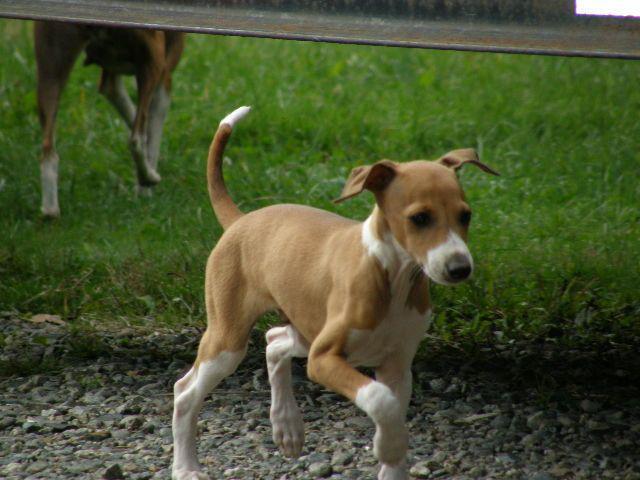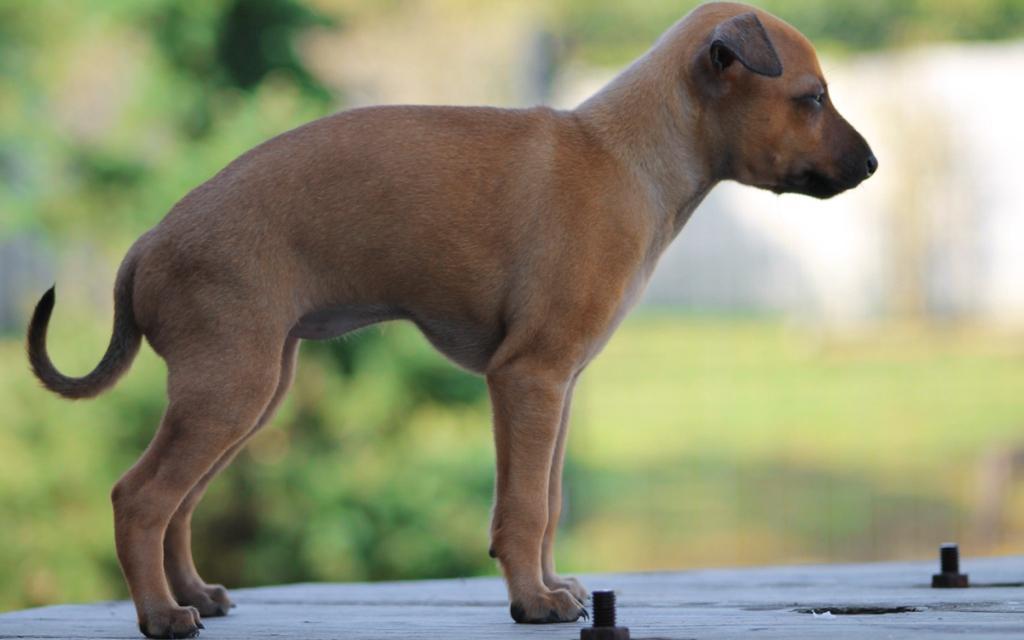The first image is the image on the left, the second image is the image on the right. Given the left and right images, does the statement "All of the dogs are outside and none of them is wearing a collar." hold true? Answer yes or no. Yes. The first image is the image on the left, the second image is the image on the right. Assess this claim about the two images: "In one image, are two dogs facing towards the camera.". Correct or not? Answer yes or no. No. 